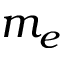Convert formula to latex. <formula><loc_0><loc_0><loc_500><loc_500>m _ { e }</formula> 